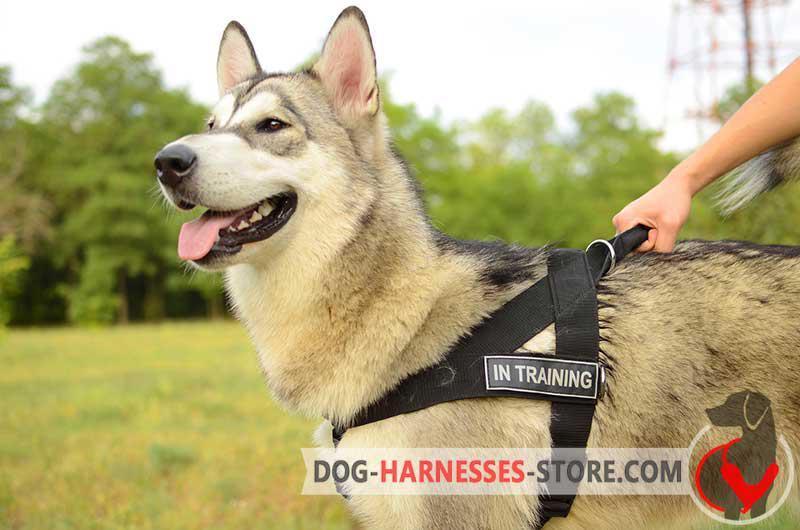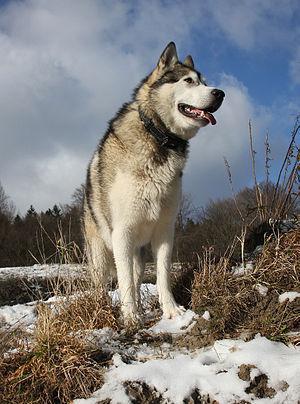The first image is the image on the left, the second image is the image on the right. Considering the images on both sides, is "The left and right image contains the same number of dogs with one sitting and the other standing outside." valid? Answer yes or no. No. The first image is the image on the left, the second image is the image on the right. Analyze the images presented: Is the assertion "Each dog has an open mouth and one dog is wearing a harness." valid? Answer yes or no. Yes. 